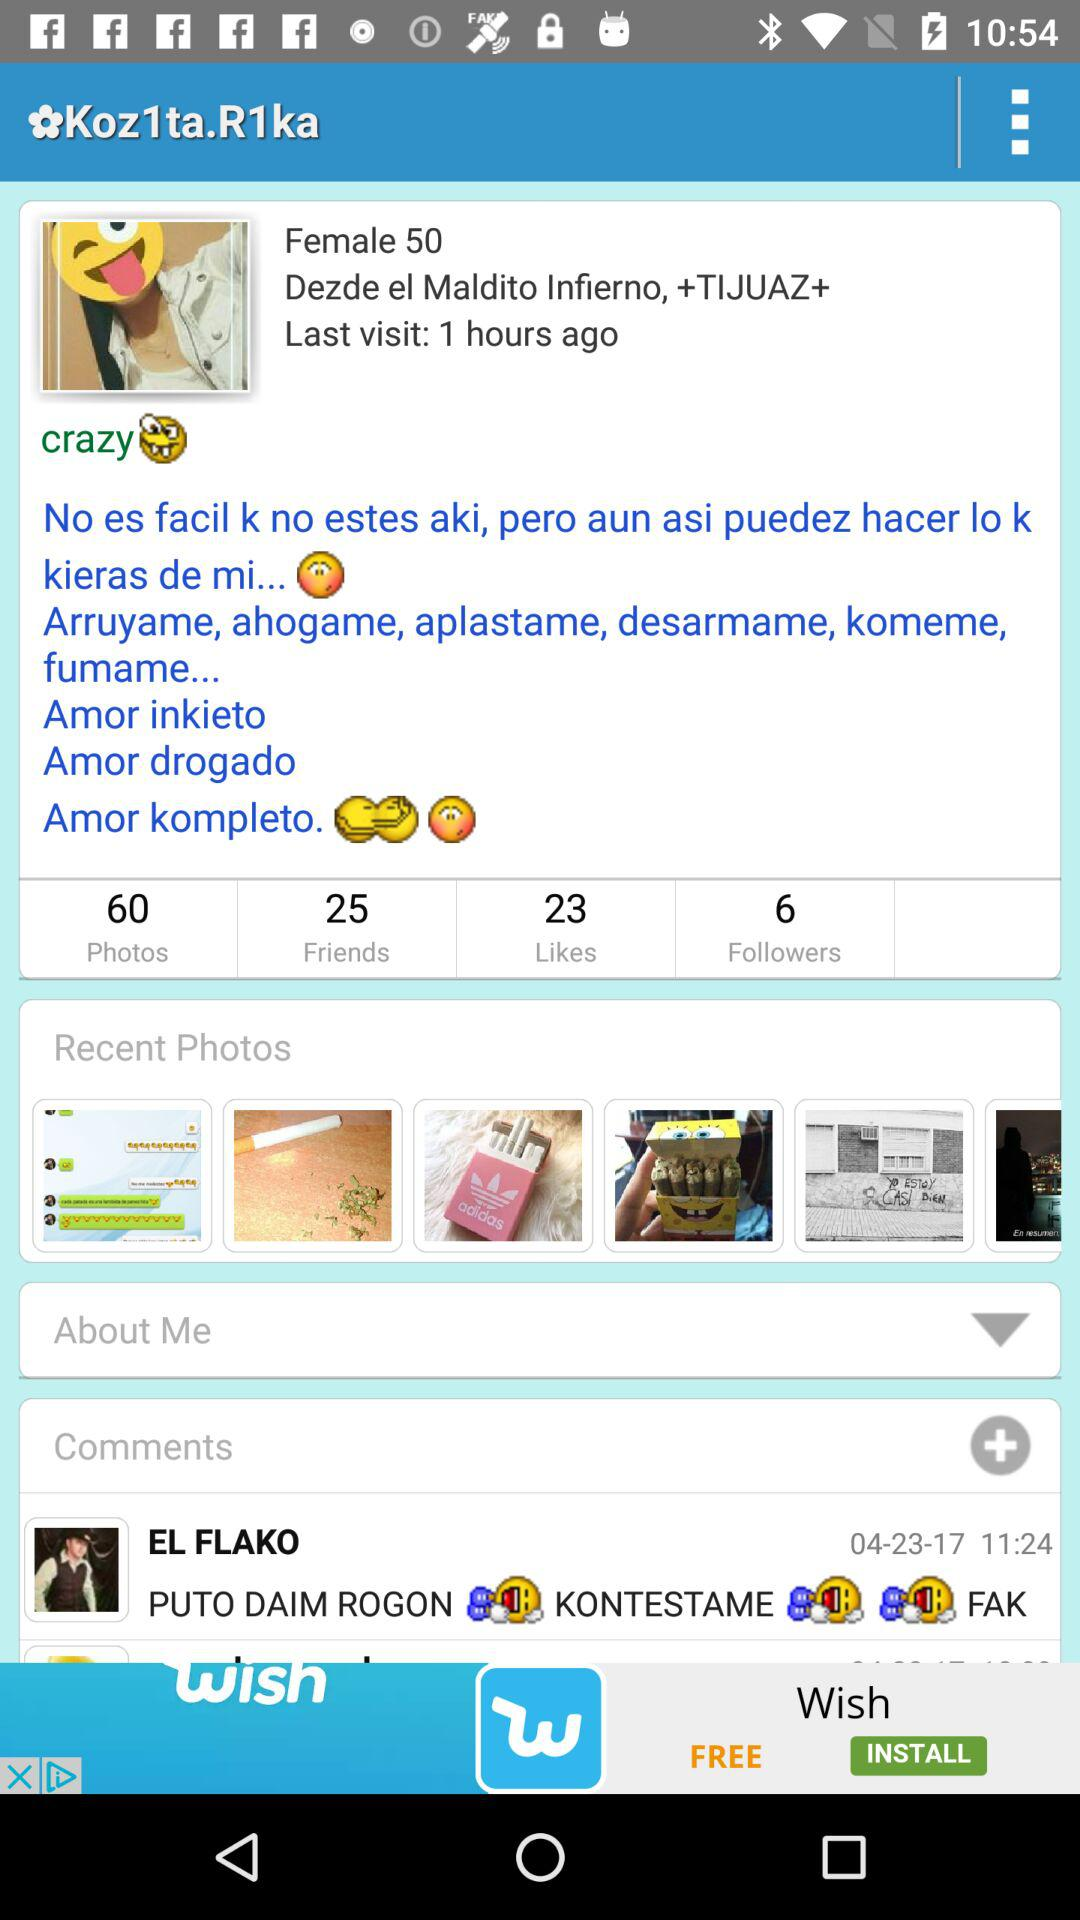What's the total number of photos? The total number of photos is 60. 